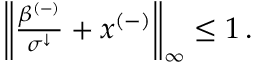Convert formula to latex. <formula><loc_0><loc_0><loc_500><loc_500>\begin{array} { r } { \left \| \frac { \beta ^ { ( - ) } } { \sigma ^ { \downarrow } } + x ^ { ( - ) } \right \| _ { \infty } \leq 1 \, . } \end{array}</formula> 